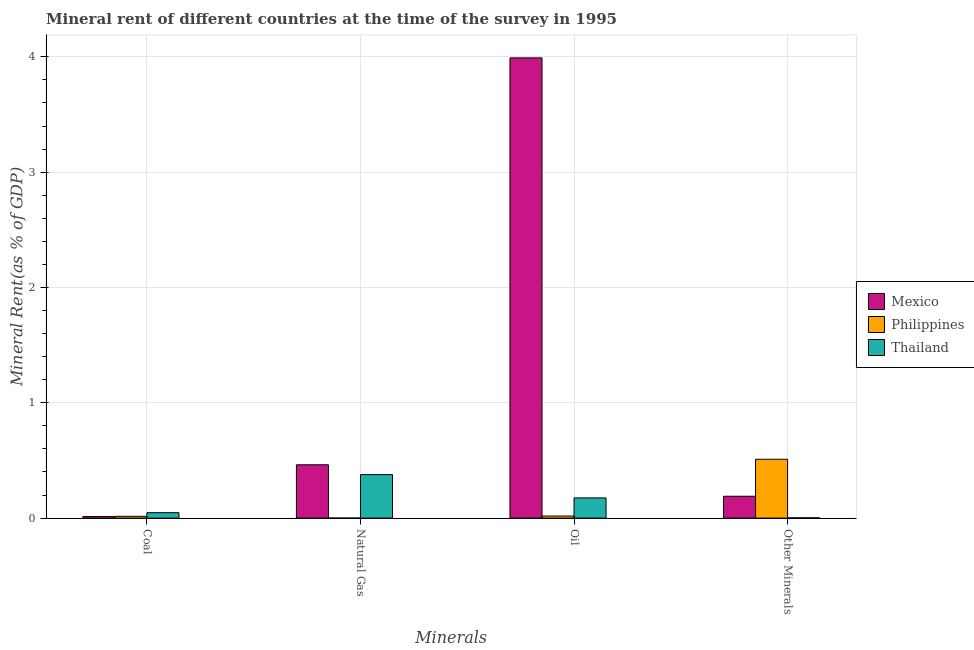Are the number of bars on each tick of the X-axis equal?
Provide a succinct answer. Yes. What is the label of the 1st group of bars from the left?
Offer a very short reply. Coal. What is the coal rent in Thailand?
Make the answer very short. 0.05. Across all countries, what is the maximum  rent of other minerals?
Keep it short and to the point. 0.51. Across all countries, what is the minimum  rent of other minerals?
Keep it short and to the point. 0. What is the total  rent of other minerals in the graph?
Your response must be concise. 0.7. What is the difference between the  rent of other minerals in Thailand and that in Philippines?
Make the answer very short. -0.51. What is the difference between the coal rent in Mexico and the natural gas rent in Thailand?
Offer a very short reply. -0.36. What is the average natural gas rent per country?
Provide a succinct answer. 0.28. What is the difference between the oil rent and natural gas rent in Philippines?
Your answer should be compact. 0.02. What is the ratio of the coal rent in Philippines to that in Mexico?
Provide a succinct answer. 1.15. Is the natural gas rent in Mexico less than that in Philippines?
Your answer should be very brief. No. What is the difference between the highest and the second highest natural gas rent?
Your answer should be compact. 0.09. What is the difference between the highest and the lowest oil rent?
Provide a short and direct response. 3.97. Is the sum of the natural gas rent in Thailand and Philippines greater than the maximum coal rent across all countries?
Your answer should be compact. Yes. What does the 3rd bar from the left in Natural Gas represents?
Your response must be concise. Thailand. How many bars are there?
Make the answer very short. 12. Are all the bars in the graph horizontal?
Make the answer very short. No. How many countries are there in the graph?
Offer a terse response. 3. What is the difference between two consecutive major ticks on the Y-axis?
Provide a short and direct response. 1. Are the values on the major ticks of Y-axis written in scientific E-notation?
Offer a terse response. No. Does the graph contain any zero values?
Offer a terse response. No. Does the graph contain grids?
Keep it short and to the point. Yes. How are the legend labels stacked?
Ensure brevity in your answer.  Vertical. What is the title of the graph?
Provide a short and direct response. Mineral rent of different countries at the time of the survey in 1995. What is the label or title of the X-axis?
Provide a short and direct response. Minerals. What is the label or title of the Y-axis?
Ensure brevity in your answer.  Mineral Rent(as % of GDP). What is the Mineral Rent(as % of GDP) in Mexico in Coal?
Ensure brevity in your answer.  0.01. What is the Mineral Rent(as % of GDP) in Philippines in Coal?
Your response must be concise. 0.02. What is the Mineral Rent(as % of GDP) of Thailand in Coal?
Give a very brief answer. 0.05. What is the Mineral Rent(as % of GDP) in Mexico in Natural Gas?
Offer a terse response. 0.46. What is the Mineral Rent(as % of GDP) of Philippines in Natural Gas?
Your answer should be very brief. 0. What is the Mineral Rent(as % of GDP) in Thailand in Natural Gas?
Offer a terse response. 0.38. What is the Mineral Rent(as % of GDP) in Mexico in Oil?
Offer a terse response. 3.99. What is the Mineral Rent(as % of GDP) of Philippines in Oil?
Give a very brief answer. 0.02. What is the Mineral Rent(as % of GDP) of Thailand in Oil?
Provide a succinct answer. 0.18. What is the Mineral Rent(as % of GDP) in Mexico in Other Minerals?
Keep it short and to the point. 0.19. What is the Mineral Rent(as % of GDP) in Philippines in Other Minerals?
Provide a short and direct response. 0.51. What is the Mineral Rent(as % of GDP) in Thailand in Other Minerals?
Your answer should be very brief. 0. Across all Minerals, what is the maximum Mineral Rent(as % of GDP) in Mexico?
Your answer should be very brief. 3.99. Across all Minerals, what is the maximum Mineral Rent(as % of GDP) in Philippines?
Provide a succinct answer. 0.51. Across all Minerals, what is the maximum Mineral Rent(as % of GDP) of Thailand?
Your answer should be very brief. 0.38. Across all Minerals, what is the minimum Mineral Rent(as % of GDP) in Mexico?
Ensure brevity in your answer.  0.01. Across all Minerals, what is the minimum Mineral Rent(as % of GDP) of Philippines?
Provide a short and direct response. 0. Across all Minerals, what is the minimum Mineral Rent(as % of GDP) in Thailand?
Your answer should be very brief. 0. What is the total Mineral Rent(as % of GDP) of Mexico in the graph?
Provide a short and direct response. 4.66. What is the total Mineral Rent(as % of GDP) in Philippines in the graph?
Make the answer very short. 0.54. What is the total Mineral Rent(as % of GDP) in Thailand in the graph?
Provide a short and direct response. 0.6. What is the difference between the Mineral Rent(as % of GDP) of Mexico in Coal and that in Natural Gas?
Give a very brief answer. -0.45. What is the difference between the Mineral Rent(as % of GDP) of Philippines in Coal and that in Natural Gas?
Ensure brevity in your answer.  0.02. What is the difference between the Mineral Rent(as % of GDP) of Thailand in Coal and that in Natural Gas?
Offer a terse response. -0.33. What is the difference between the Mineral Rent(as % of GDP) of Mexico in Coal and that in Oil?
Provide a short and direct response. -3.98. What is the difference between the Mineral Rent(as % of GDP) in Philippines in Coal and that in Oil?
Ensure brevity in your answer.  -0. What is the difference between the Mineral Rent(as % of GDP) in Thailand in Coal and that in Oil?
Provide a succinct answer. -0.13. What is the difference between the Mineral Rent(as % of GDP) in Mexico in Coal and that in Other Minerals?
Provide a short and direct response. -0.18. What is the difference between the Mineral Rent(as % of GDP) in Philippines in Coal and that in Other Minerals?
Offer a very short reply. -0.49. What is the difference between the Mineral Rent(as % of GDP) of Thailand in Coal and that in Other Minerals?
Provide a succinct answer. 0.04. What is the difference between the Mineral Rent(as % of GDP) in Mexico in Natural Gas and that in Oil?
Your answer should be compact. -3.53. What is the difference between the Mineral Rent(as % of GDP) in Philippines in Natural Gas and that in Oil?
Provide a succinct answer. -0.02. What is the difference between the Mineral Rent(as % of GDP) of Thailand in Natural Gas and that in Oil?
Provide a succinct answer. 0.2. What is the difference between the Mineral Rent(as % of GDP) in Mexico in Natural Gas and that in Other Minerals?
Your answer should be compact. 0.27. What is the difference between the Mineral Rent(as % of GDP) in Philippines in Natural Gas and that in Other Minerals?
Make the answer very short. -0.51. What is the difference between the Mineral Rent(as % of GDP) of Thailand in Natural Gas and that in Other Minerals?
Offer a very short reply. 0.37. What is the difference between the Mineral Rent(as % of GDP) of Mexico in Oil and that in Other Minerals?
Offer a terse response. 3.8. What is the difference between the Mineral Rent(as % of GDP) in Philippines in Oil and that in Other Minerals?
Offer a terse response. -0.49. What is the difference between the Mineral Rent(as % of GDP) in Thailand in Oil and that in Other Minerals?
Your answer should be very brief. 0.17. What is the difference between the Mineral Rent(as % of GDP) in Mexico in Coal and the Mineral Rent(as % of GDP) in Philippines in Natural Gas?
Ensure brevity in your answer.  0.01. What is the difference between the Mineral Rent(as % of GDP) of Mexico in Coal and the Mineral Rent(as % of GDP) of Thailand in Natural Gas?
Provide a succinct answer. -0.36. What is the difference between the Mineral Rent(as % of GDP) of Philippines in Coal and the Mineral Rent(as % of GDP) of Thailand in Natural Gas?
Your response must be concise. -0.36. What is the difference between the Mineral Rent(as % of GDP) in Mexico in Coal and the Mineral Rent(as % of GDP) in Philippines in Oil?
Provide a short and direct response. -0. What is the difference between the Mineral Rent(as % of GDP) of Mexico in Coal and the Mineral Rent(as % of GDP) of Thailand in Oil?
Keep it short and to the point. -0.16. What is the difference between the Mineral Rent(as % of GDP) of Philippines in Coal and the Mineral Rent(as % of GDP) of Thailand in Oil?
Give a very brief answer. -0.16. What is the difference between the Mineral Rent(as % of GDP) in Mexico in Coal and the Mineral Rent(as % of GDP) in Philippines in Other Minerals?
Your response must be concise. -0.5. What is the difference between the Mineral Rent(as % of GDP) in Mexico in Coal and the Mineral Rent(as % of GDP) in Thailand in Other Minerals?
Make the answer very short. 0.01. What is the difference between the Mineral Rent(as % of GDP) of Philippines in Coal and the Mineral Rent(as % of GDP) of Thailand in Other Minerals?
Provide a succinct answer. 0.01. What is the difference between the Mineral Rent(as % of GDP) of Mexico in Natural Gas and the Mineral Rent(as % of GDP) of Philippines in Oil?
Your answer should be very brief. 0.44. What is the difference between the Mineral Rent(as % of GDP) in Mexico in Natural Gas and the Mineral Rent(as % of GDP) in Thailand in Oil?
Your answer should be very brief. 0.29. What is the difference between the Mineral Rent(as % of GDP) in Philippines in Natural Gas and the Mineral Rent(as % of GDP) in Thailand in Oil?
Provide a succinct answer. -0.17. What is the difference between the Mineral Rent(as % of GDP) of Mexico in Natural Gas and the Mineral Rent(as % of GDP) of Philippines in Other Minerals?
Your response must be concise. -0.05. What is the difference between the Mineral Rent(as % of GDP) of Mexico in Natural Gas and the Mineral Rent(as % of GDP) of Thailand in Other Minerals?
Keep it short and to the point. 0.46. What is the difference between the Mineral Rent(as % of GDP) in Philippines in Natural Gas and the Mineral Rent(as % of GDP) in Thailand in Other Minerals?
Your answer should be very brief. -0. What is the difference between the Mineral Rent(as % of GDP) in Mexico in Oil and the Mineral Rent(as % of GDP) in Philippines in Other Minerals?
Your answer should be very brief. 3.48. What is the difference between the Mineral Rent(as % of GDP) of Mexico in Oil and the Mineral Rent(as % of GDP) of Thailand in Other Minerals?
Make the answer very short. 3.99. What is the difference between the Mineral Rent(as % of GDP) in Philippines in Oil and the Mineral Rent(as % of GDP) in Thailand in Other Minerals?
Your answer should be very brief. 0.02. What is the average Mineral Rent(as % of GDP) of Mexico per Minerals?
Keep it short and to the point. 1.16. What is the average Mineral Rent(as % of GDP) of Philippines per Minerals?
Provide a short and direct response. 0.14. What is the average Mineral Rent(as % of GDP) of Thailand per Minerals?
Provide a short and direct response. 0.15. What is the difference between the Mineral Rent(as % of GDP) in Mexico and Mineral Rent(as % of GDP) in Philippines in Coal?
Make the answer very short. -0. What is the difference between the Mineral Rent(as % of GDP) in Mexico and Mineral Rent(as % of GDP) in Thailand in Coal?
Ensure brevity in your answer.  -0.03. What is the difference between the Mineral Rent(as % of GDP) in Philippines and Mineral Rent(as % of GDP) in Thailand in Coal?
Make the answer very short. -0.03. What is the difference between the Mineral Rent(as % of GDP) of Mexico and Mineral Rent(as % of GDP) of Philippines in Natural Gas?
Your answer should be very brief. 0.46. What is the difference between the Mineral Rent(as % of GDP) in Mexico and Mineral Rent(as % of GDP) in Thailand in Natural Gas?
Your answer should be very brief. 0.09. What is the difference between the Mineral Rent(as % of GDP) in Philippines and Mineral Rent(as % of GDP) in Thailand in Natural Gas?
Provide a succinct answer. -0.38. What is the difference between the Mineral Rent(as % of GDP) of Mexico and Mineral Rent(as % of GDP) of Philippines in Oil?
Your answer should be compact. 3.97. What is the difference between the Mineral Rent(as % of GDP) in Mexico and Mineral Rent(as % of GDP) in Thailand in Oil?
Give a very brief answer. 3.82. What is the difference between the Mineral Rent(as % of GDP) in Philippines and Mineral Rent(as % of GDP) in Thailand in Oil?
Provide a short and direct response. -0.16. What is the difference between the Mineral Rent(as % of GDP) of Mexico and Mineral Rent(as % of GDP) of Philippines in Other Minerals?
Provide a succinct answer. -0.32. What is the difference between the Mineral Rent(as % of GDP) in Mexico and Mineral Rent(as % of GDP) in Thailand in Other Minerals?
Offer a terse response. 0.19. What is the difference between the Mineral Rent(as % of GDP) of Philippines and Mineral Rent(as % of GDP) of Thailand in Other Minerals?
Provide a short and direct response. 0.51. What is the ratio of the Mineral Rent(as % of GDP) in Mexico in Coal to that in Natural Gas?
Provide a short and direct response. 0.03. What is the ratio of the Mineral Rent(as % of GDP) of Philippines in Coal to that in Natural Gas?
Your answer should be compact. 36.29. What is the ratio of the Mineral Rent(as % of GDP) in Thailand in Coal to that in Natural Gas?
Provide a short and direct response. 0.13. What is the ratio of the Mineral Rent(as % of GDP) of Mexico in Coal to that in Oil?
Keep it short and to the point. 0. What is the ratio of the Mineral Rent(as % of GDP) of Philippines in Coal to that in Oil?
Your answer should be very brief. 0.86. What is the ratio of the Mineral Rent(as % of GDP) in Thailand in Coal to that in Oil?
Provide a short and direct response. 0.27. What is the ratio of the Mineral Rent(as % of GDP) in Mexico in Coal to that in Other Minerals?
Offer a terse response. 0.07. What is the ratio of the Mineral Rent(as % of GDP) in Philippines in Coal to that in Other Minerals?
Give a very brief answer. 0.03. What is the ratio of the Mineral Rent(as % of GDP) in Thailand in Coal to that in Other Minerals?
Offer a very short reply. 19.59. What is the ratio of the Mineral Rent(as % of GDP) in Mexico in Natural Gas to that in Oil?
Keep it short and to the point. 0.12. What is the ratio of the Mineral Rent(as % of GDP) in Philippines in Natural Gas to that in Oil?
Your response must be concise. 0.02. What is the ratio of the Mineral Rent(as % of GDP) of Thailand in Natural Gas to that in Oil?
Give a very brief answer. 2.15. What is the ratio of the Mineral Rent(as % of GDP) in Mexico in Natural Gas to that in Other Minerals?
Your response must be concise. 2.44. What is the ratio of the Mineral Rent(as % of GDP) in Philippines in Natural Gas to that in Other Minerals?
Your answer should be compact. 0. What is the ratio of the Mineral Rent(as % of GDP) of Thailand in Natural Gas to that in Other Minerals?
Offer a terse response. 156.34. What is the ratio of the Mineral Rent(as % of GDP) of Mexico in Oil to that in Other Minerals?
Make the answer very short. 21.04. What is the ratio of the Mineral Rent(as % of GDP) of Philippines in Oil to that in Other Minerals?
Provide a short and direct response. 0.04. What is the ratio of the Mineral Rent(as % of GDP) of Thailand in Oil to that in Other Minerals?
Ensure brevity in your answer.  72.68. What is the difference between the highest and the second highest Mineral Rent(as % of GDP) of Mexico?
Provide a short and direct response. 3.53. What is the difference between the highest and the second highest Mineral Rent(as % of GDP) in Philippines?
Offer a terse response. 0.49. What is the difference between the highest and the second highest Mineral Rent(as % of GDP) of Thailand?
Your answer should be compact. 0.2. What is the difference between the highest and the lowest Mineral Rent(as % of GDP) in Mexico?
Ensure brevity in your answer.  3.98. What is the difference between the highest and the lowest Mineral Rent(as % of GDP) in Philippines?
Make the answer very short. 0.51. What is the difference between the highest and the lowest Mineral Rent(as % of GDP) in Thailand?
Keep it short and to the point. 0.37. 